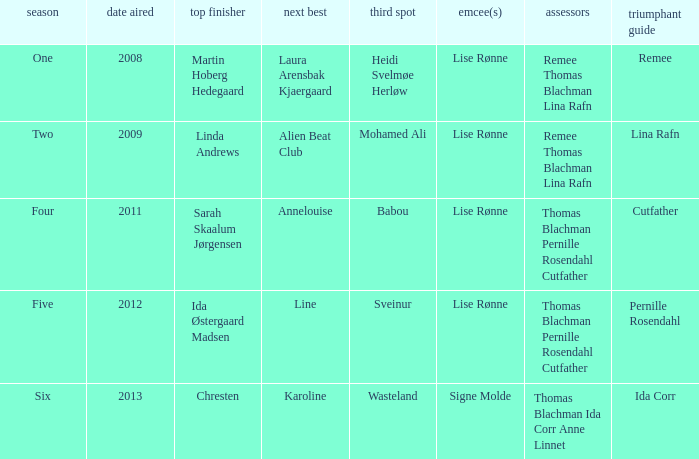Who was the runner-up when Mohamed Ali got third? Alien Beat Club. Can you parse all the data within this table? {'header': ['season', 'date aired', 'top finisher', 'next best', 'third spot', 'emcee(s)', 'assessors', 'triumphant guide'], 'rows': [['One', '2008', 'Martin Hoberg Hedegaard', 'Laura Arensbak Kjaergaard', 'Heidi Svelmøe Herløw', 'Lise Rønne', 'Remee Thomas Blachman Lina Rafn', 'Remee'], ['Two', '2009', 'Linda Andrews', 'Alien Beat Club', 'Mohamed Ali', 'Lise Rønne', 'Remee Thomas Blachman Lina Rafn', 'Lina Rafn'], ['Four', '2011', 'Sarah Skaalum Jørgensen', 'Annelouise', 'Babou', 'Lise Rønne', 'Thomas Blachman Pernille Rosendahl Cutfather', 'Cutfather'], ['Five', '2012', 'Ida Østergaard Madsen', 'Line', 'Sveinur', 'Lise Rønne', 'Thomas Blachman Pernille Rosendahl Cutfather', 'Pernille Rosendahl'], ['Six', '2013', 'Chresten', 'Karoline', 'Wasteland', 'Signe Molde', 'Thomas Blachman Ida Corr Anne Linnet', 'Ida Corr']]} 